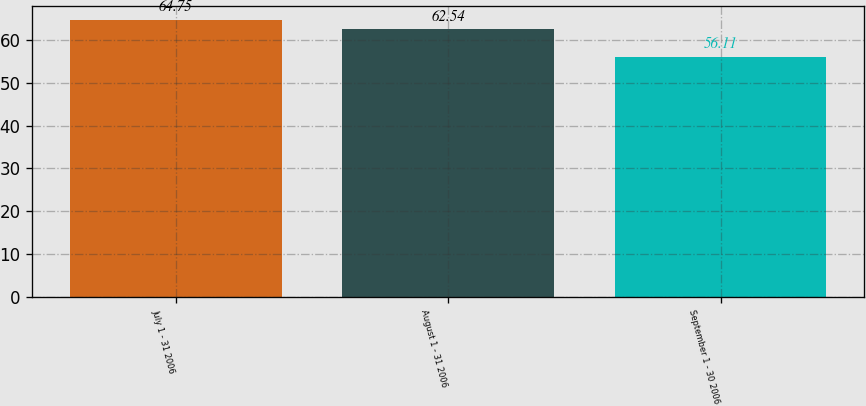Convert chart. <chart><loc_0><loc_0><loc_500><loc_500><bar_chart><fcel>July 1 - 31 2006<fcel>August 1 - 31 2006<fcel>September 1 - 30 2006<nl><fcel>64.75<fcel>62.54<fcel>56.11<nl></chart> 